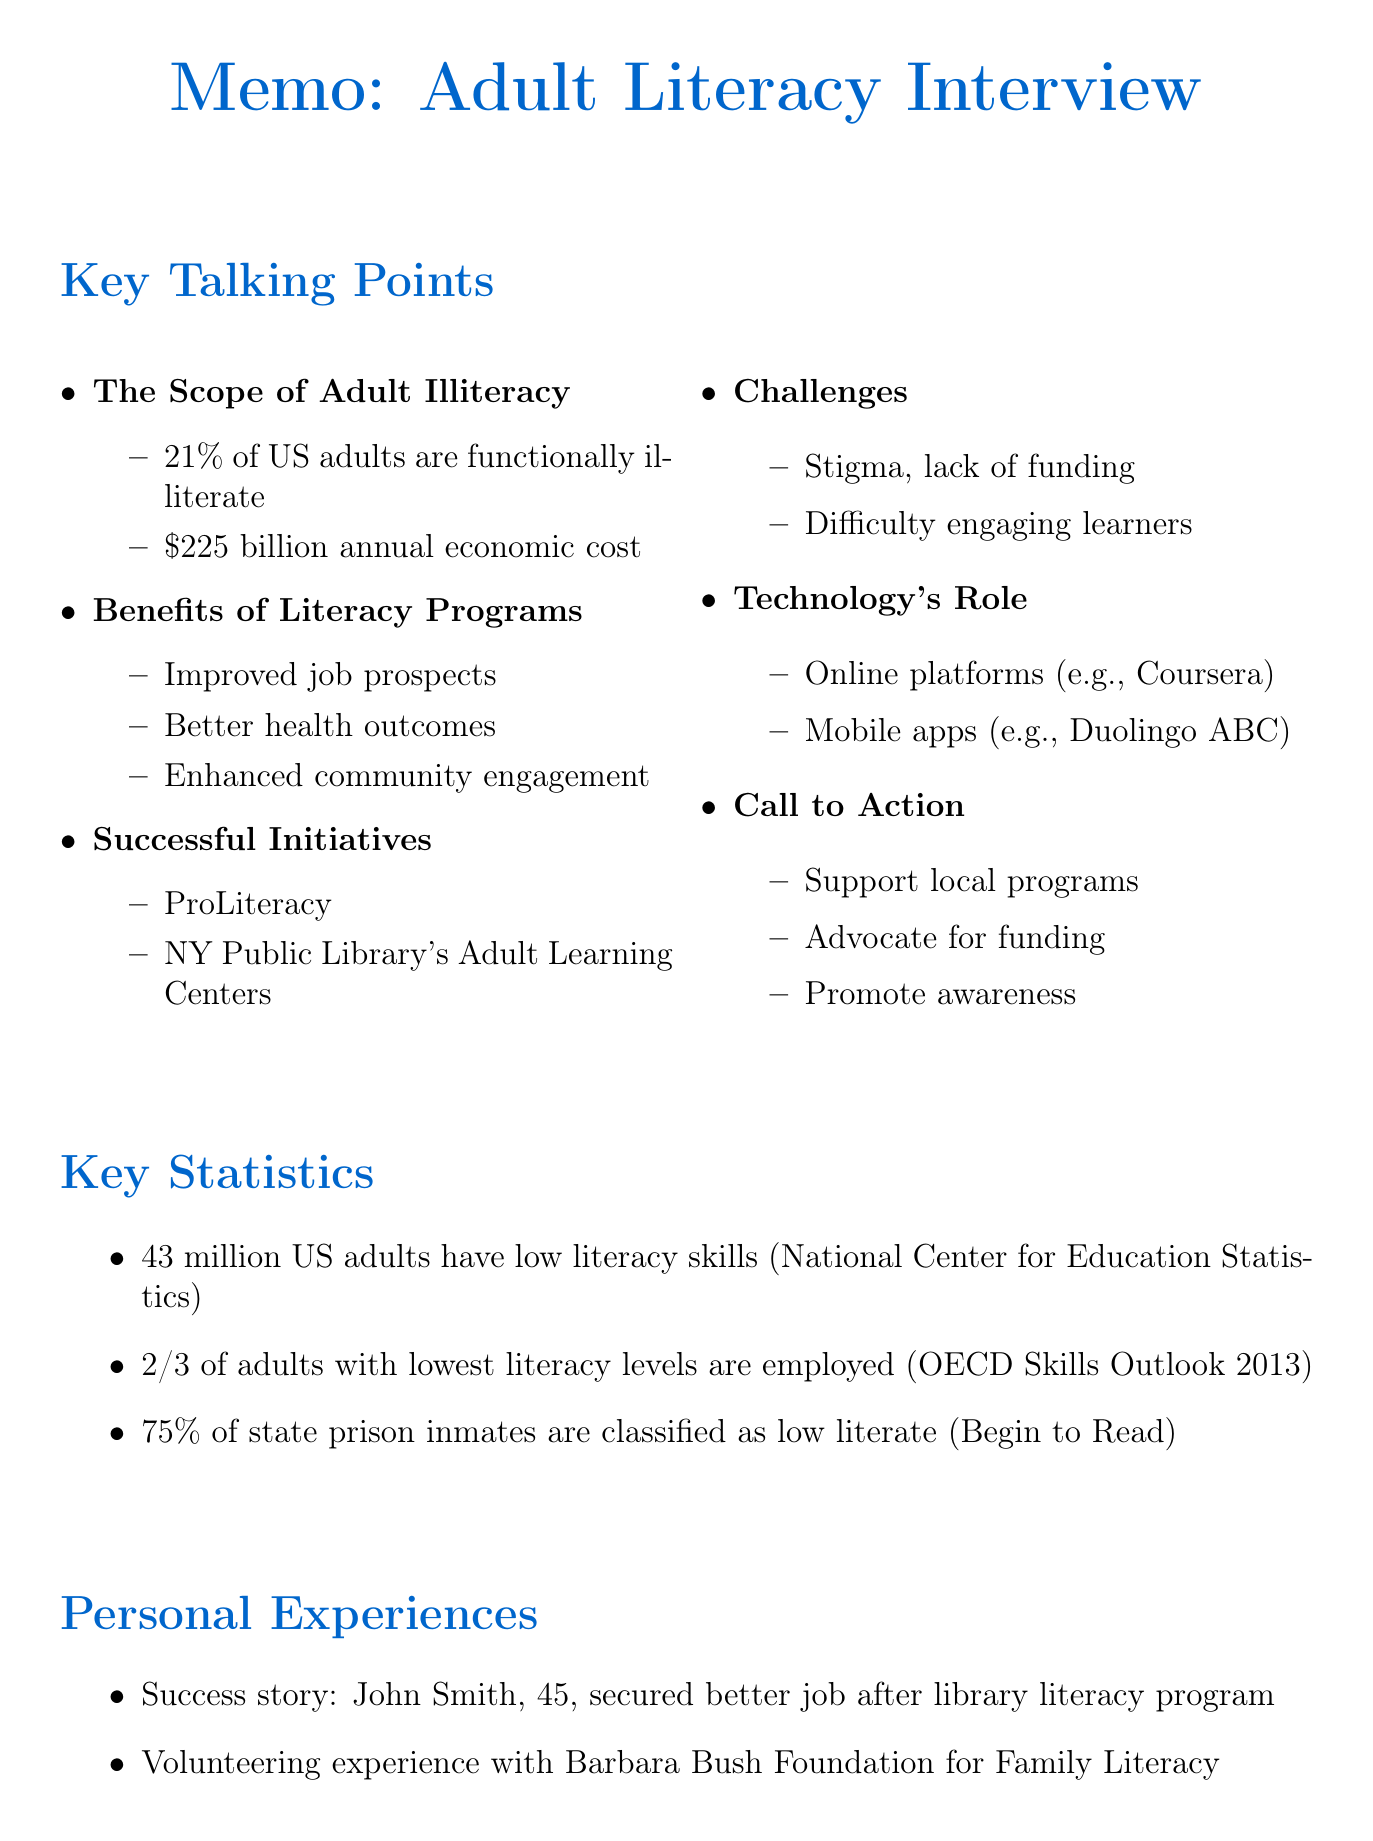What percentage of adults in the US are functionally illiterate? The document states that 21% of adults in the US are functionally illiterate.
Answer: 21% What is the annual economic cost of illiteracy in the US? The document cites the economic impact of illiteracy as costing the US economy $225 billion annually.
Answer: $225 billion Which organization is mentioned as supporting adult literacy programs? The document highlights ProLiteracy as a national organization supporting adult literacy programs.
Answer: ProLiteracy What percentage of state prison inmates are classified as low literate? According to the document, 75% of state prison inmates are classified as low literate.
Answer: 75% What is a personal success story mentioned in the document? The document mentions John Smith, who learned to read through a local library program and secured a better job.
Answer: John Smith Which mobile app is mentioned as helpful for adult literacy? The document references Duolingo ABC as a mobile app for adult literacy.
Answer: Duolingo ABC What is one of the challenges in adult literacy education listed in the document? The document points out stigma associated with adult illiteracy as a challenge.
Answer: Stigma What quote by Kofi Annan is included in the document? The document includes the quote, "Literacy is a bridge from misery to hope."
Answer: "Literacy is a bridge from misery to hope." 